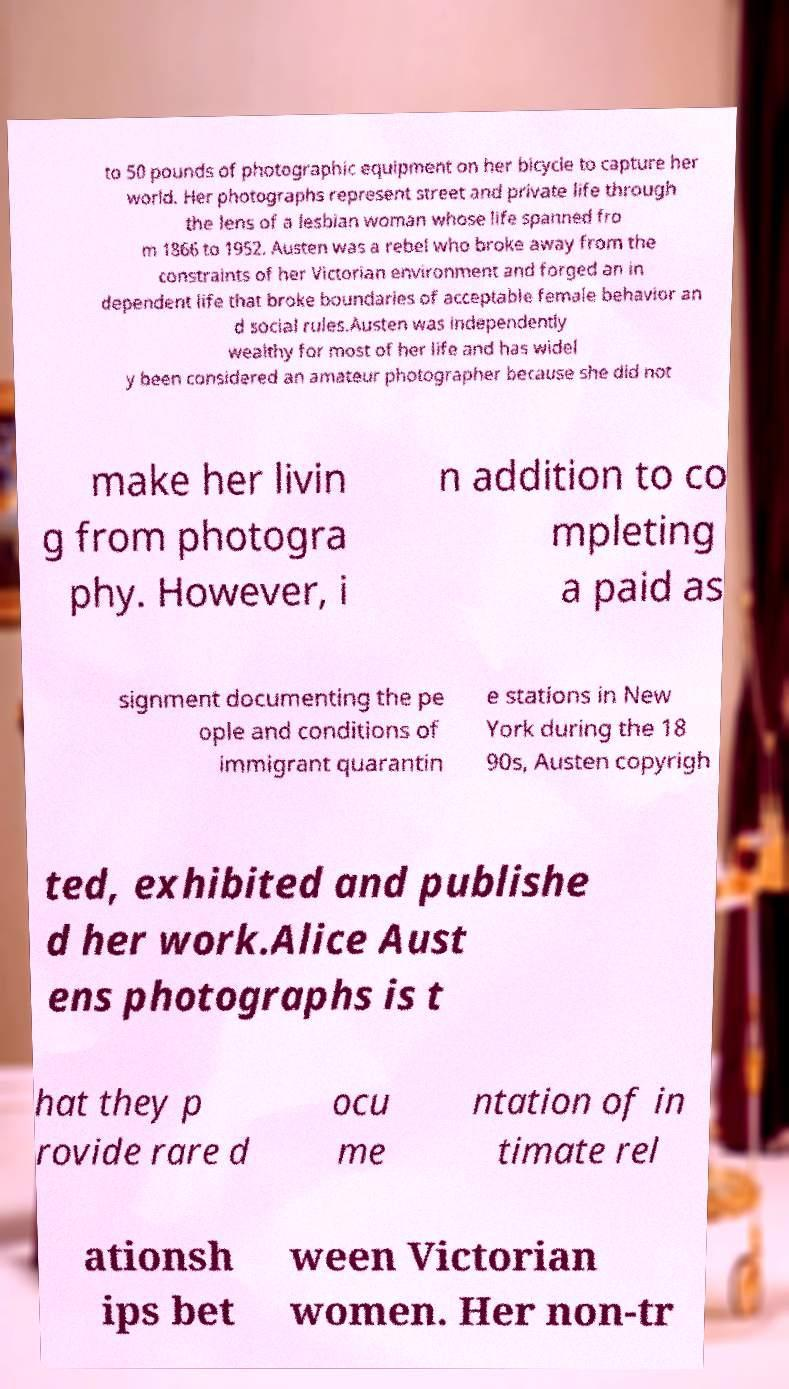What messages or text are displayed in this image? I need them in a readable, typed format. to 50 pounds of photographic equipment on her bicycle to capture her world. Her photographs represent street and private life through the lens of a lesbian woman whose life spanned fro m 1866 to 1952. Austen was a rebel who broke away from the constraints of her Victorian environment and forged an in dependent life that broke boundaries of acceptable female behavior an d social rules.Austen was independently wealthy for most of her life and has widel y been considered an amateur photographer because she did not make her livin g from photogra phy. However, i n addition to co mpleting a paid as signment documenting the pe ople and conditions of immigrant quarantin e stations in New York during the 18 90s, Austen copyrigh ted, exhibited and publishe d her work.Alice Aust ens photographs is t hat they p rovide rare d ocu me ntation of in timate rel ationsh ips bet ween Victorian women. Her non-tr 